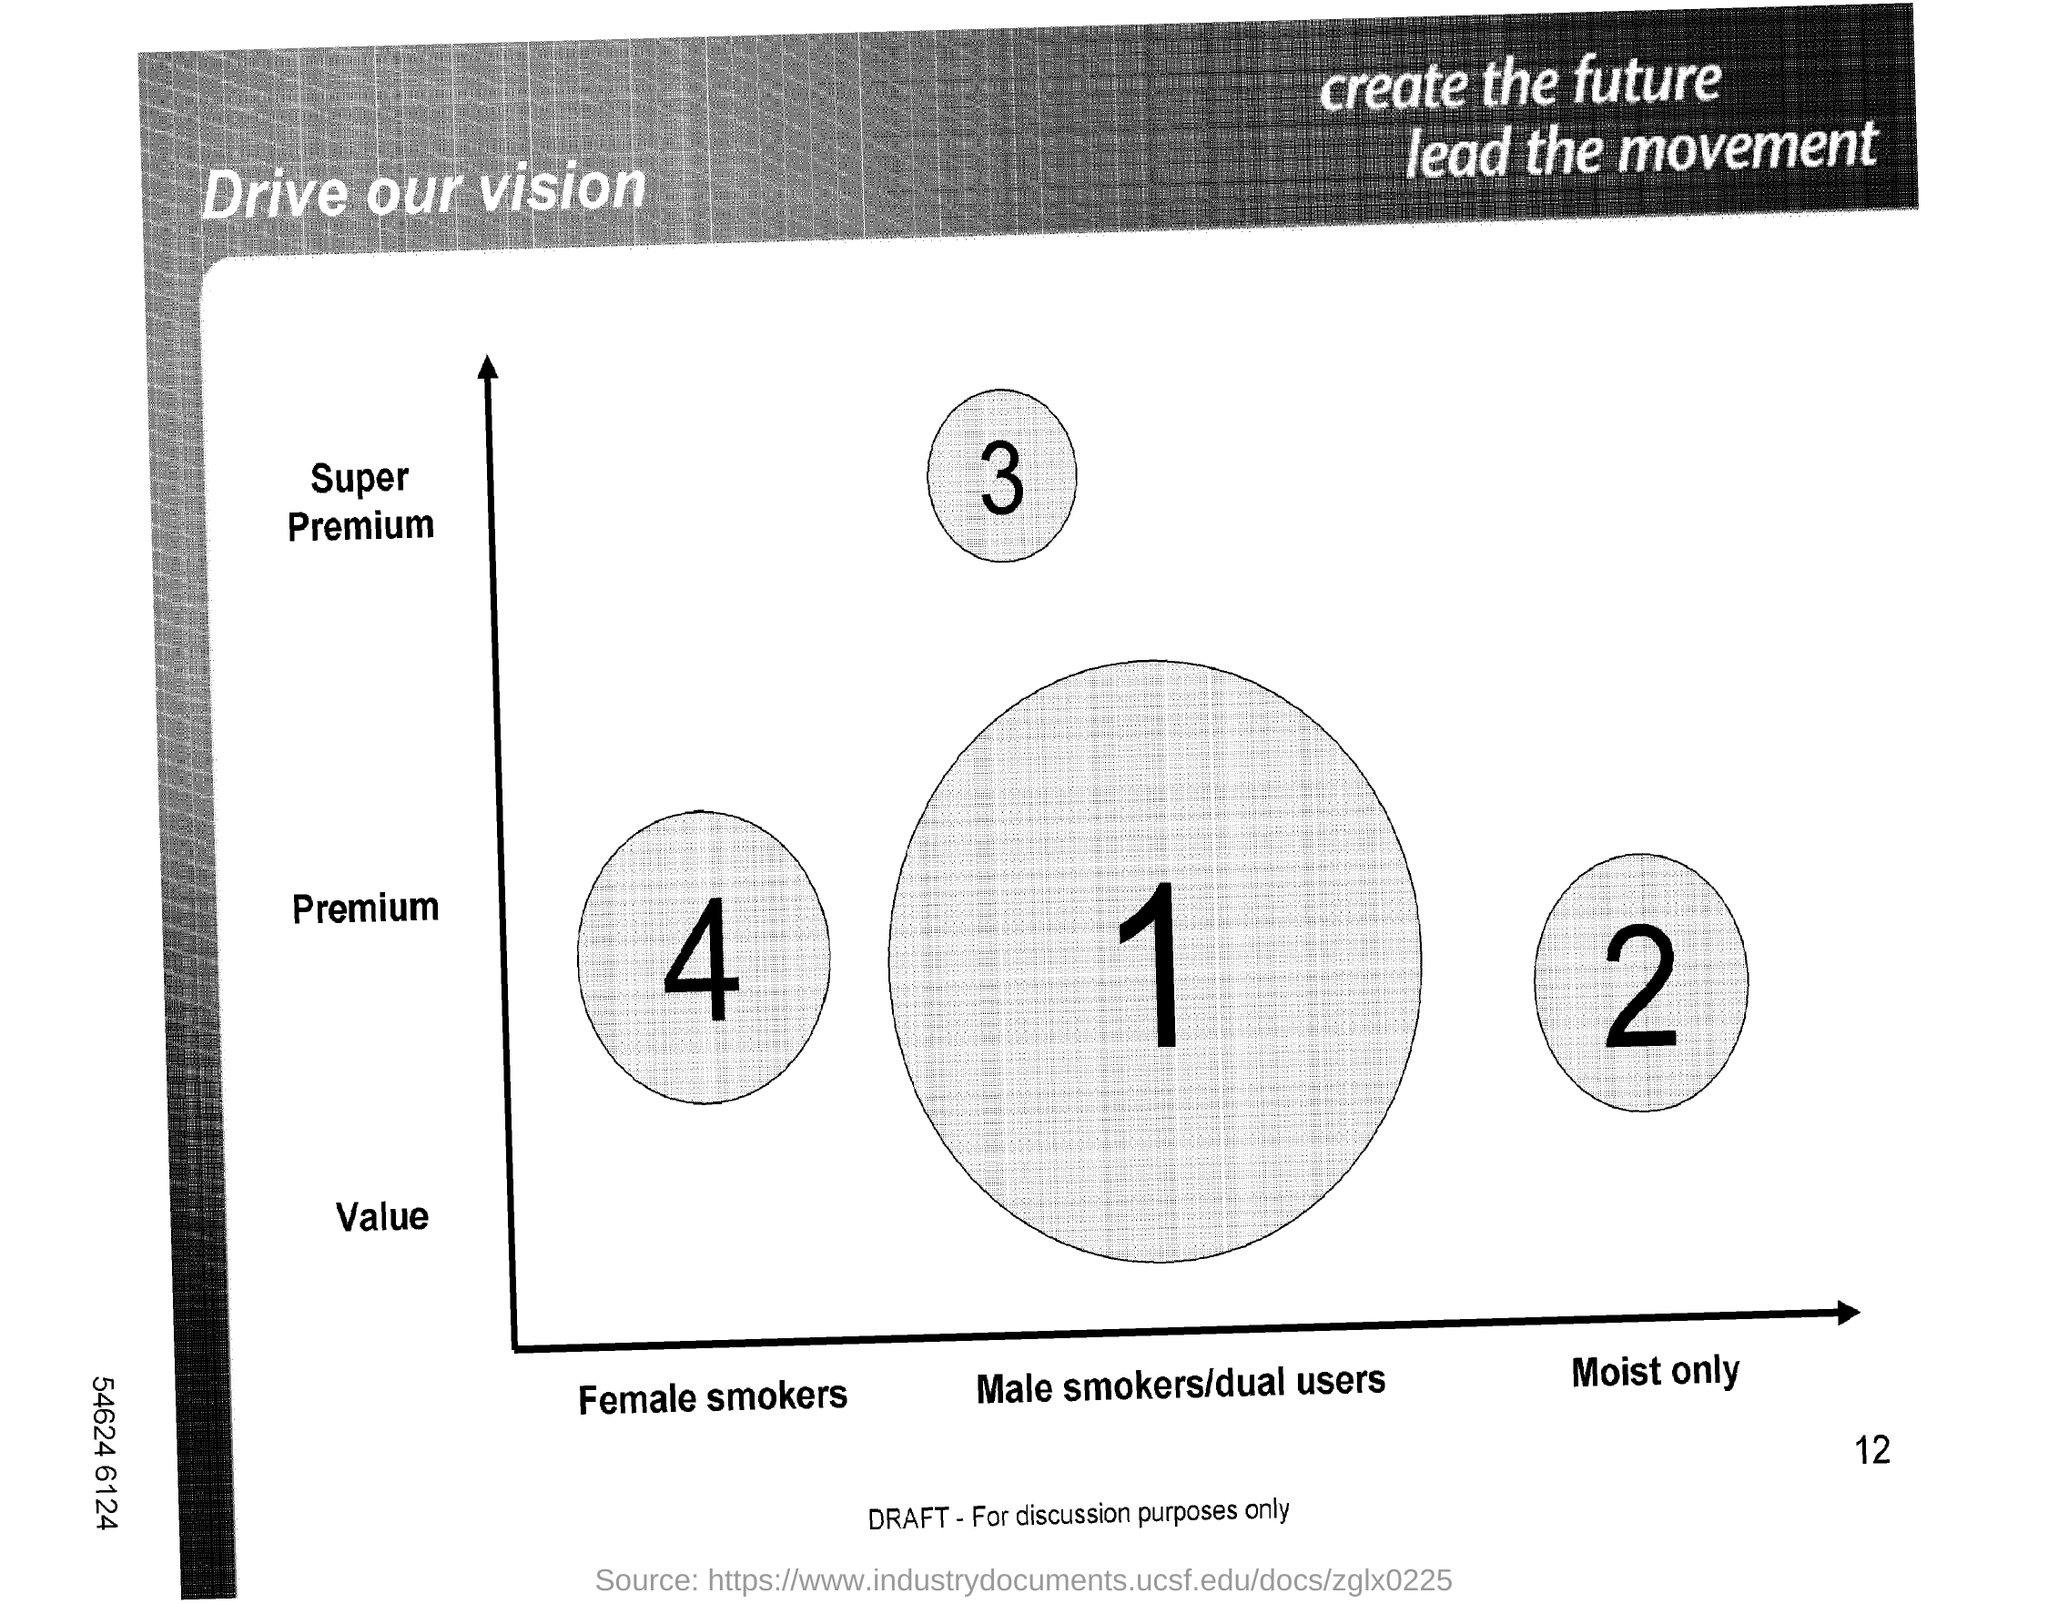What is the title in the top left corner?
Ensure brevity in your answer.  Drive our vision. What is the title in the top right corner?
Offer a terse response. Create the future lead the movement. 